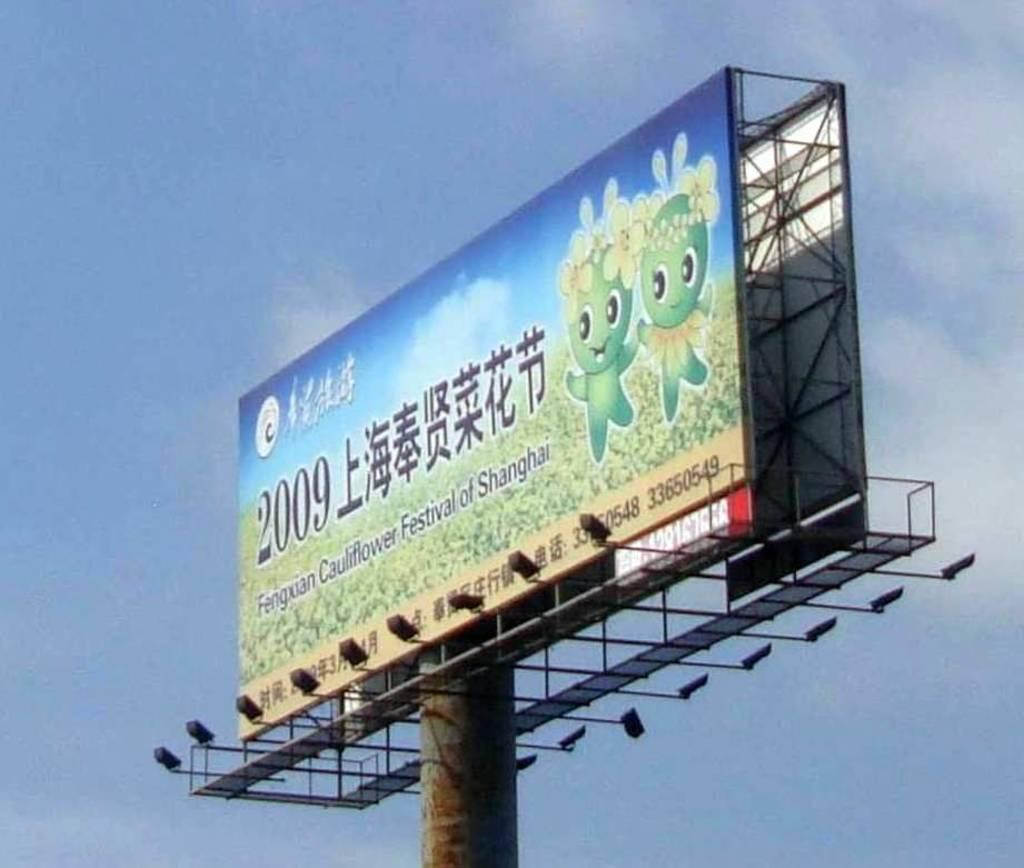<image>
Share a concise interpretation of the image provided. a 2009 year written next to some foreign language 